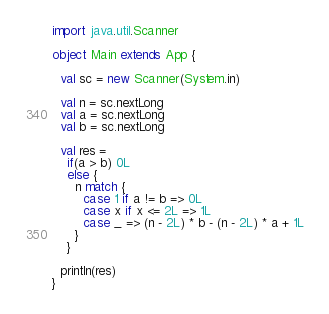Convert code to text. <code><loc_0><loc_0><loc_500><loc_500><_Scala_>import java.util.Scanner

object Main extends App {

  val sc = new Scanner(System.in)

  val n = sc.nextLong
  val a = sc.nextLong
  val b = sc.nextLong

  val res =
    if(a > b) 0L
    else {
      n match {
        case 1 if a != b => 0L
        case x if x <= 2L => 1L
        case _ => (n - 2L) * b - (n - 2L) * a + 1L
      }
    }

  println(res)
}</code> 